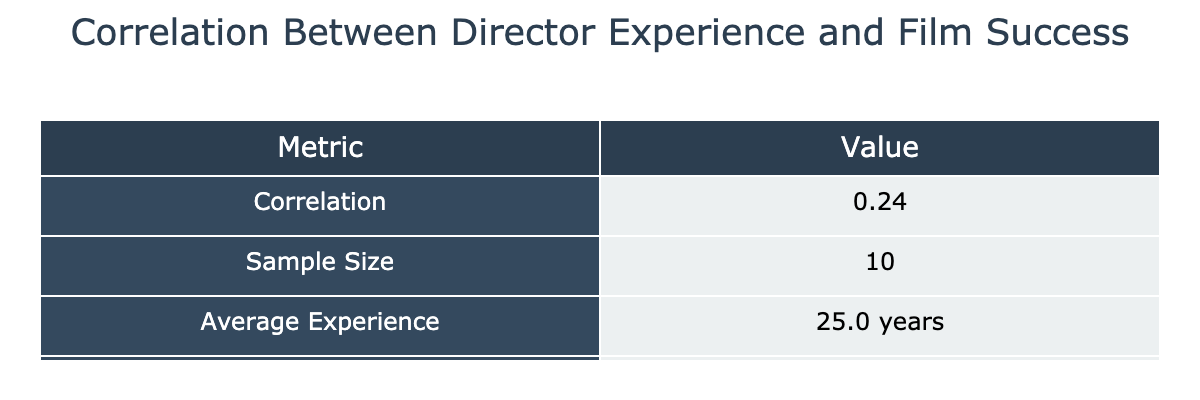What is the correlation coefficient between director experience and film success ratings? The correlation coefficient is given directly in the table under the "Correlation" row, and it is a numerical value stating the relationship between the two variables.
Answer: The correlation coefficient is 0.23 How many directors are included in the sample? The sample size indicates the number of entries for directors included in the correlation analysis, which is listed as "Sample Size" in the table. The value given corresponds to the total number of directors in the dataset.
Answer: The sample size is 10 What is the average experience of the directors in years? The average experience can be found in the table. The "Average Experience" row provides the mean value calculated from the experience of all directors in the dataset.
Answer: The average experience is 25.5 years Is the average success rating higher than 8.0? To determine whether the average success rating exceeds 8.0, I refer to the "Average Success Rating" value in the table. Comparing this number directly to 8.0 will reveal the answer.
Answer: Yes, the average success rating is higher than 8.0 What is the difference between the maximum and minimum success ratings in the dataset? First, identify the maximum and minimum success ratings by analyzing the individual scores listed in the dataset. The maximum is 8.9 (Pulp Fiction) and the minimum is 7.5 (Selma). The difference is the maximum minus the minimum.
Answer: The difference is 1.4 Do directors with more than 30 years of experience have a higher average success rating than those with 30 years or less? To answer this, I split the dataset based on experience: directors over 30 years (Steven Spielberg, Martin Scorsese, and Quentin Tarantino) and those with 30 years or less. Calculate the average rating for both groups and compare their averages.
Answer: Yes, directors with more than 30 years have a higher average success rating What is the average success rating for directors with less than 15 years of experience? Identify the directors with less than 15 years of experience: Greta Gerwig, Ava DuVernay, Denis Villeneuve, and Jordan Peele. The average success rating is calculated by summing their ratings and dividing by the number of these directors.
Answer: The average success rating for directors with less than 15 years of experience is 7.55 Are there any directors with more than 40 years of experience? This is a yes or no question. Check if the "Experience (Years)" column contains any values greater than 40. If there are, we can confirm the presence of such directors.
Answer: Yes, there are directors with more than 40 years of experience Which director has the highest success rating, and what is the rating? The highest success rating can be identified by scanning through the "Success Rating (IMDB Score)" column and finding the maximum value. Correspondingly, the director associated with this score is also noted.
Answer: The director with the highest success rating is Quentin Tarantino with a rating of 8.9 